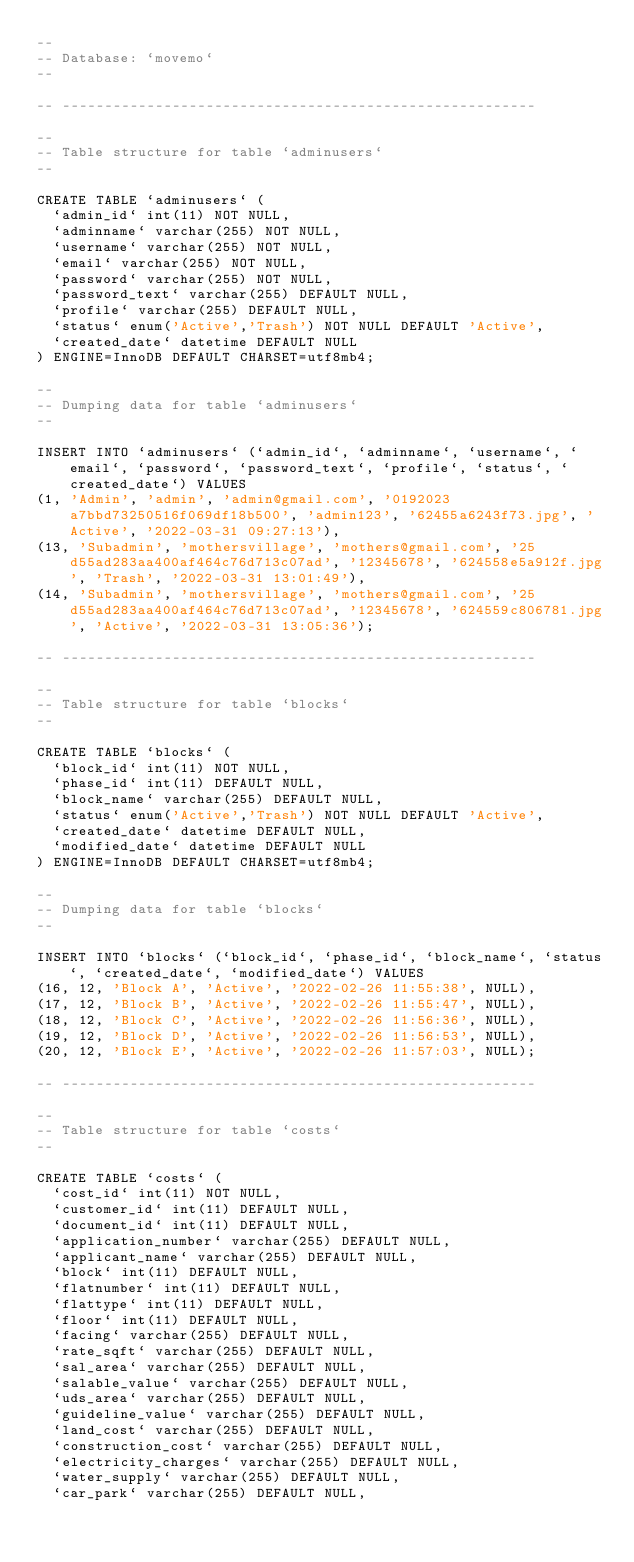Convert code to text. <code><loc_0><loc_0><loc_500><loc_500><_SQL_>--
-- Database: `movemo`
--

-- --------------------------------------------------------

--
-- Table structure for table `adminusers`
--

CREATE TABLE `adminusers` (
  `admin_id` int(11) NOT NULL,
  `adminname` varchar(255) NOT NULL,
  `username` varchar(255) NOT NULL,
  `email` varchar(255) NOT NULL,
  `password` varchar(255) NOT NULL,
  `password_text` varchar(255) DEFAULT NULL,
  `profile` varchar(255) DEFAULT NULL,
  `status` enum('Active','Trash') NOT NULL DEFAULT 'Active',
  `created_date` datetime DEFAULT NULL
) ENGINE=InnoDB DEFAULT CHARSET=utf8mb4;

--
-- Dumping data for table `adminusers`
--

INSERT INTO `adminusers` (`admin_id`, `adminname`, `username`, `email`, `password`, `password_text`, `profile`, `status`, `created_date`) VALUES
(1, 'Admin', 'admin', 'admin@gmail.com', '0192023a7bbd73250516f069df18b500', 'admin123', '62455a6243f73.jpg', 'Active', '2022-03-31 09:27:13'),
(13, 'Subadmin', 'mothersvillage', 'mothers@gmail.com', '25d55ad283aa400af464c76d713c07ad', '12345678', '624558e5a912f.jpg', 'Trash', '2022-03-31 13:01:49'),
(14, 'Subadmin', 'mothersvillage', 'mothers@gmail.com', '25d55ad283aa400af464c76d713c07ad', '12345678', '624559c806781.jpg', 'Active', '2022-03-31 13:05:36');

-- --------------------------------------------------------

--
-- Table structure for table `blocks`
--

CREATE TABLE `blocks` (
  `block_id` int(11) NOT NULL,
  `phase_id` int(11) DEFAULT NULL,
  `block_name` varchar(255) DEFAULT NULL,
  `status` enum('Active','Trash') NOT NULL DEFAULT 'Active',
  `created_date` datetime DEFAULT NULL,
  `modified_date` datetime DEFAULT NULL
) ENGINE=InnoDB DEFAULT CHARSET=utf8mb4;

--
-- Dumping data for table `blocks`
--

INSERT INTO `blocks` (`block_id`, `phase_id`, `block_name`, `status`, `created_date`, `modified_date`) VALUES
(16, 12, 'Block A', 'Active', '2022-02-26 11:55:38', NULL),
(17, 12, 'Block B', 'Active', '2022-02-26 11:55:47', NULL),
(18, 12, 'Block C', 'Active', '2022-02-26 11:56:36', NULL),
(19, 12, 'Block D', 'Active', '2022-02-26 11:56:53', NULL),
(20, 12, 'Block E', 'Active', '2022-02-26 11:57:03', NULL);

-- --------------------------------------------------------

--
-- Table structure for table `costs`
--

CREATE TABLE `costs` (
  `cost_id` int(11) NOT NULL,
  `customer_id` int(11) DEFAULT NULL,
  `document_id` int(11) DEFAULT NULL,
  `application_number` varchar(255) DEFAULT NULL,
  `applicant_name` varchar(255) DEFAULT NULL,
  `block` int(11) DEFAULT NULL,
  `flatnumber` int(11) DEFAULT NULL,
  `flattype` int(11) DEFAULT NULL,
  `floor` int(11) DEFAULT NULL,
  `facing` varchar(255) DEFAULT NULL,
  `rate_sqft` varchar(255) DEFAULT NULL,
  `sal_area` varchar(255) DEFAULT NULL,
  `salable_value` varchar(255) DEFAULT NULL,
  `uds_area` varchar(255) DEFAULT NULL,
  `guideline_value` varchar(255) DEFAULT NULL,
  `land_cost` varchar(255) DEFAULT NULL,
  `construction_cost` varchar(255) DEFAULT NULL,
  `electricity_charges` varchar(255) DEFAULT NULL,
  `water_supply` varchar(255) DEFAULT NULL,
  `car_park` varchar(255) DEFAULT NULL,</code> 